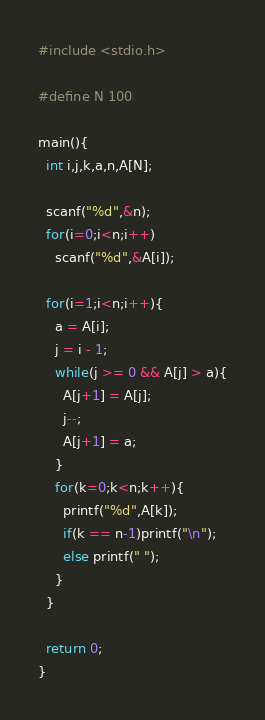Convert code to text. <code><loc_0><loc_0><loc_500><loc_500><_C_>#include <stdio.h>

#define N 100

main(){
  int i,j,k,a,n,A[N];

  scanf("%d",&n);
  for(i=0;i<n;i++)
    scanf("%d",&A[i]);

  for(i=1;i<n;i++){
    a = A[i];
    j = i - 1;
    while(j >= 0 && A[j] > a){
      A[j+1] = A[j];
      j--;
      A[j+1] = a;
    }
    for(k=0;k<n;k++){
      printf("%d",A[k]);
      if(k == n-1)printf("\n");
      else printf(" ");
    }
  }

  return 0;
}</code> 